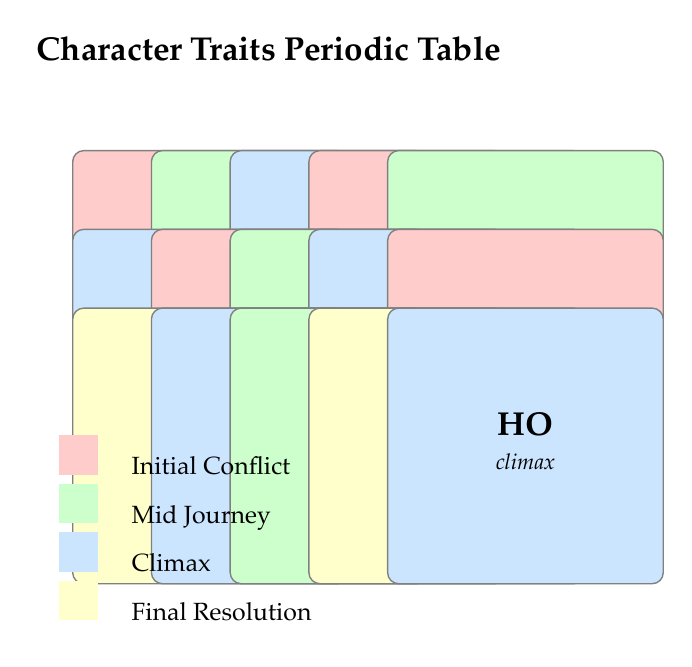What character trait corresponds with the symbol "FR"? Referring to the table, we can see that the symbol "FR" is associated with the trait "Friendship."
Answer: Friendship Which character traits are present during the "Climax" stage? By reviewing the rows corresponding to the "Climax" stage, we find the traits "Resilience," "Love," "Fearlessness," "Stealth," and "Honour."
Answer: Resilience, Love, Fearlessness, Stealth, Honour Is "Narcissism" associated with the "Final Resolution" stage? Looking at the table, "Narcissism" is listed under the "Initial Conflict" stage, which means it is not linked to the "Final Resolution."
Answer: No How many traits are situated in the "Mid Journey" stage? By counting the rows under the "Mid Journey" classification, we find three traits: "Empathy," "Friendship," and "Pride." Therefore, there are three traits in this stage.
Answer: Three Which trait has the strongest emotional influence in character actions? Analyzing the table shows that "Love" is described as a powerful emotion that drives characters' actions, making it influential in the narrative.
Answer: Love What is the relationship between "Courage" and "Intellect" regarding their development stages? Both "Courage" and "Intellect" are associated with the "Initial Conflict" stage, indicating that they are important traits for characters when they first face challenges.
Answer: They are both in the Initial Conflict stage Identify the trait that emphasizes a moral dilemma. The trait "Stealth" is noted for representing skill and a potential moral dilemma, indicating a conflict between actions and ethics.
Answer: Stealth Does the "Greed" trait lead to potential redemption arcs? The description for "Greed" mentions it creating conflicts that can lead to redemption arcs, confirming that this trait has such potential.
Answer: Yes What is the common theme of traits during the "Final Resolution" stage? The traits "Patience" and "Wisdom" are present in this stage, which emphasizes qualities that enable characters to reflect and grow from their experiences, suggesting a theme of maturity and resolution.
Answer: Maturity and resolution 